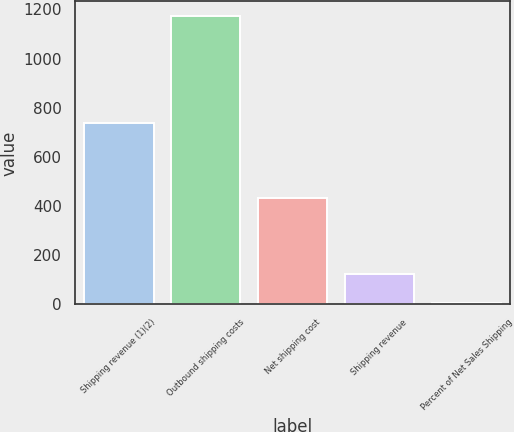<chart> <loc_0><loc_0><loc_500><loc_500><bar_chart><fcel>Shipping revenue (1)(2)<fcel>Outbound shipping costs<fcel>Net shipping cost<fcel>Shipping revenue<fcel>Percent of Net Sales Shipping<nl><fcel>740<fcel>1174<fcel>434<fcel>121.9<fcel>5<nl></chart> 